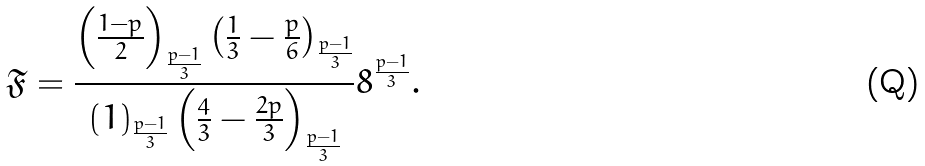Convert formula to latex. <formula><loc_0><loc_0><loc_500><loc_500>\mathfrak { F } = \frac { \left ( \frac { 1 - p } 2 \right ) _ { \frac { p - 1 } { 3 } } \left ( \frac { 1 } { 3 } - \frac { p } 6 \right ) _ { \frac { p - 1 } { 3 } } } { ( 1 ) _ { \frac { p - 1 } { 3 } } \left ( \frac { 4 } { 3 } - \frac { 2 p } 3 \right ) _ { \frac { p - 1 } { 3 } } } 8 ^ { \frac { p - 1 } { 3 } } .</formula> 